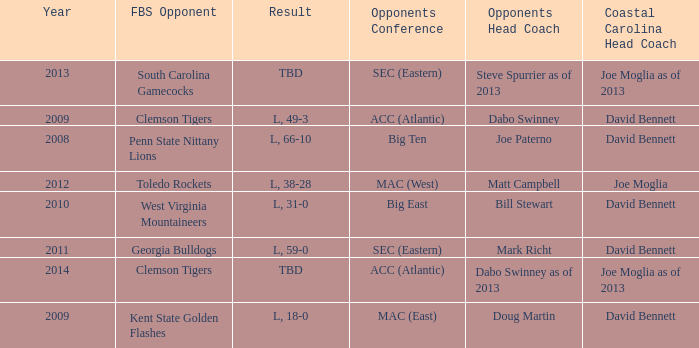How many head coaches did Kent state golden flashes have? 1.0. 